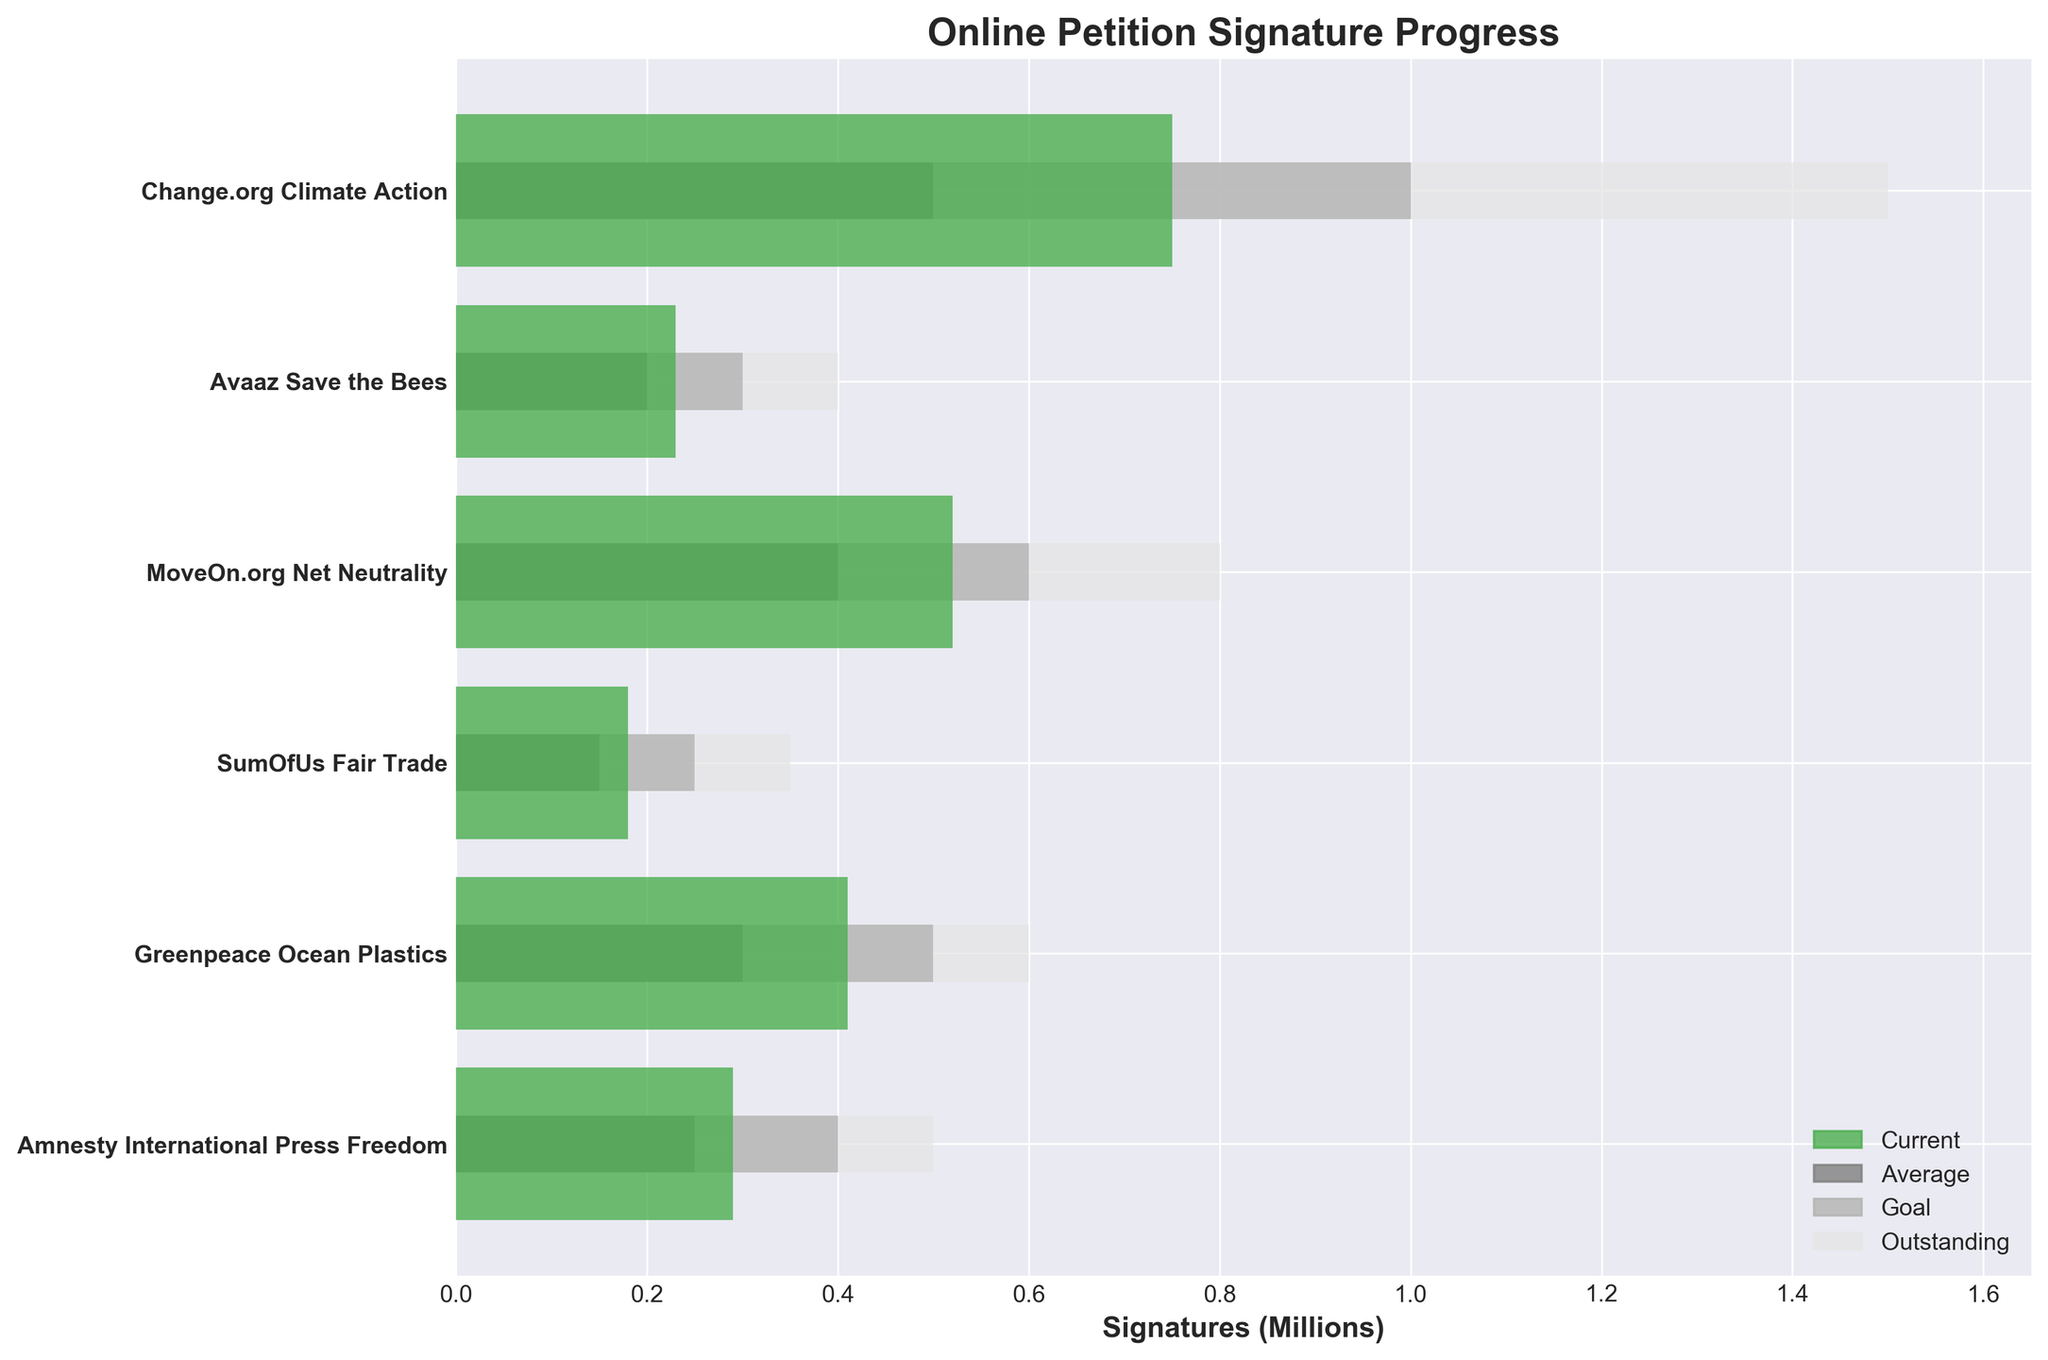How many campaigns are displayed in the figure? Count the number of campaigns listed on the y-axis of the plot.
Answer: 6 What is the title of the figure? Look at the top of the chart to see the title.
Answer: Online Petition Signature Progress Which campaign has the highest goal of signatures? Look at the goal values represented by the medium grey bars. Compare the lengths across all campaigns to find the longest one.
Answer: Change.org Climate Action Which campaign has the lowest number of current signatures? Check the lengths of the dark green bars representing current signatures and identify the shortest one.
Answer: SumOfUs Fair Trade What is the color used for representing the 'Outstanding' signatures in the figure? Observe the colors in the chart legend and identify which color is associated with 'Outstanding'.
Answer: Light grey How many campaigns have their current signatures exceeding their average signatures? Compare the length of the dark green bars (current) to the lengths of the dark grey bars (average) for each campaign. Count the campaigns where the dark green bar is longer.
Answer: 4 Which campaign shows the most significant difference between current and goal signatures? Measure the difference in lengths between the dark green bar and the medium grey bar for each campaign. Identify the campaign with the largest difference.
Answer: Change.org Climate Action What is the total number of campaigns where the current signatures are at least 75% of the goal? Calculate 75% of the goal values (medium grey bars) and compare them with the current values (dark green bars) to see how many meet or exceed this threshold.
Answer: 4 Compare the campaigns Greenpeace Ocean Plastics and Avaaz Save the Bees. Which has more current signatures, and by how much? Look at the lengths of the dark green bars for both campaigns. Subtract the current signatures of Avaaz Save the Bees from those of Greenpeace Ocean Plastics.
Answer: Greenpeace Ocean Plastics, by 180,000 signatures What is the typical range of outstanding signatures across all campaigns? Examine the lengths of the light grey bars to estimate the range by identifying the minimum and maximum values.
Answer: From 350,000 to 1,500,000 